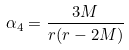Convert formula to latex. <formula><loc_0><loc_0><loc_500><loc_500>\alpha _ { 4 } = \frac { 3 M } { r ( r - 2 M ) }</formula> 